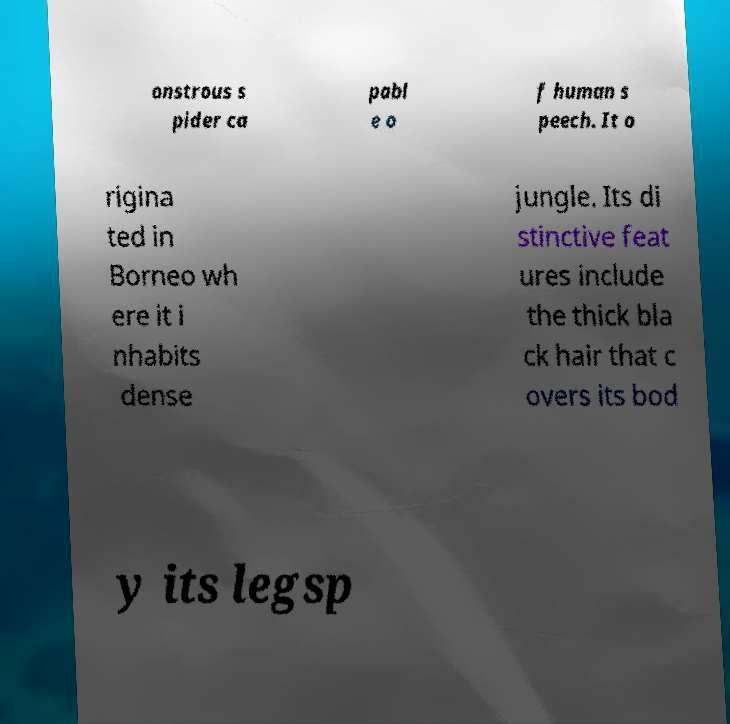What messages or text are displayed in this image? I need them in a readable, typed format. onstrous s pider ca pabl e o f human s peech. It o rigina ted in Borneo wh ere it i nhabits dense jungle. Its di stinctive feat ures include the thick bla ck hair that c overs its bod y its legsp 